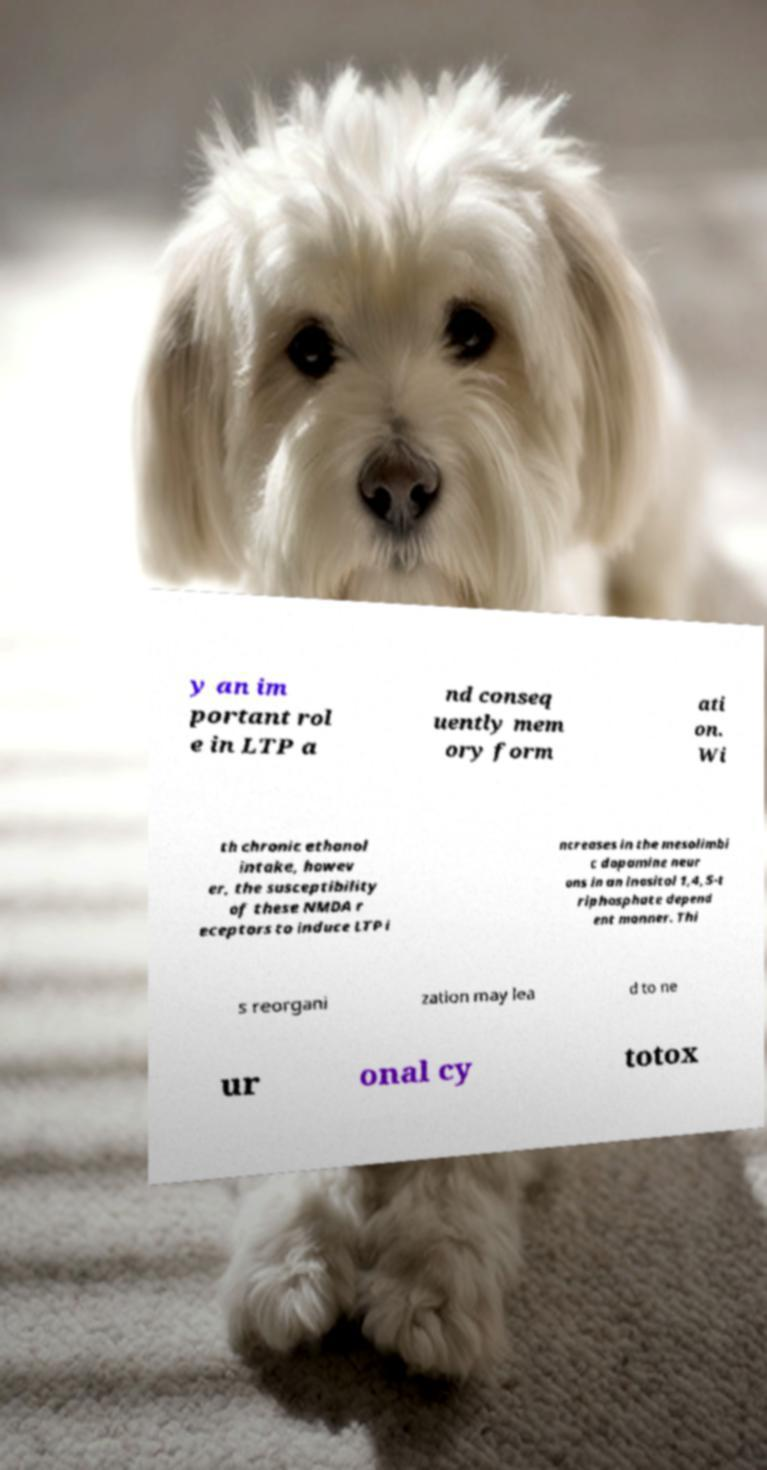Could you assist in decoding the text presented in this image and type it out clearly? y an im portant rol e in LTP a nd conseq uently mem ory form ati on. Wi th chronic ethanol intake, howev er, the susceptibility of these NMDA r eceptors to induce LTP i ncreases in the mesolimbi c dopamine neur ons in an inositol 1,4,5-t riphosphate depend ent manner. Thi s reorgani zation may lea d to ne ur onal cy totox 